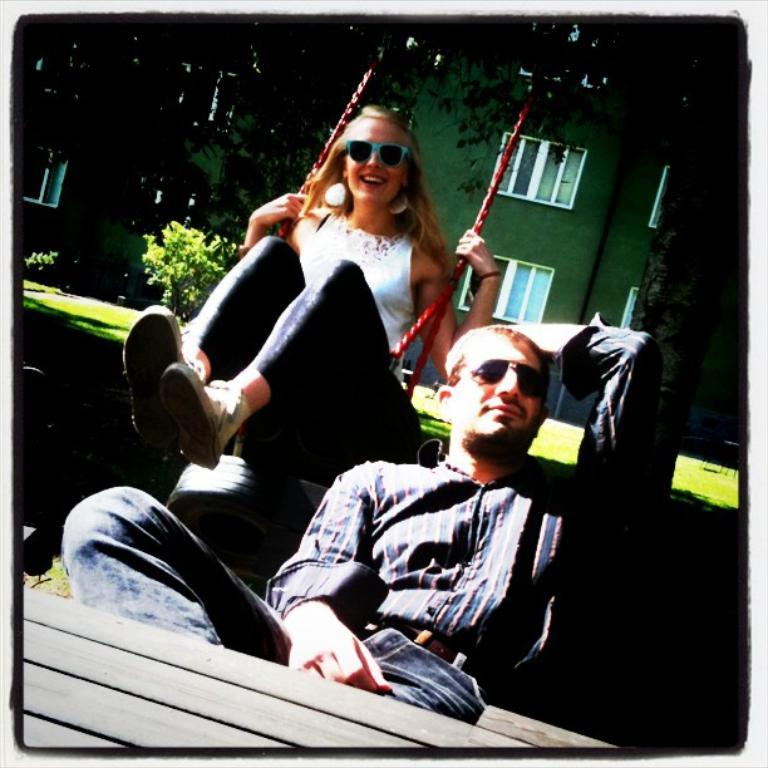How many people are in the image? There are two persons in the image. What are the two people doing in the image? One person is sitting on a bench, and the other person is sitting on a swing. What can be seen in the background of the image? There is a building, plants, and a tree in the background of the image. What type of table is visible in the image? There is no table present in the image. What event is being shown in the image? The image does not depict a specific event; it simply shows two people sitting on a bench and a swing with a background of a building, plants, and a tree. 